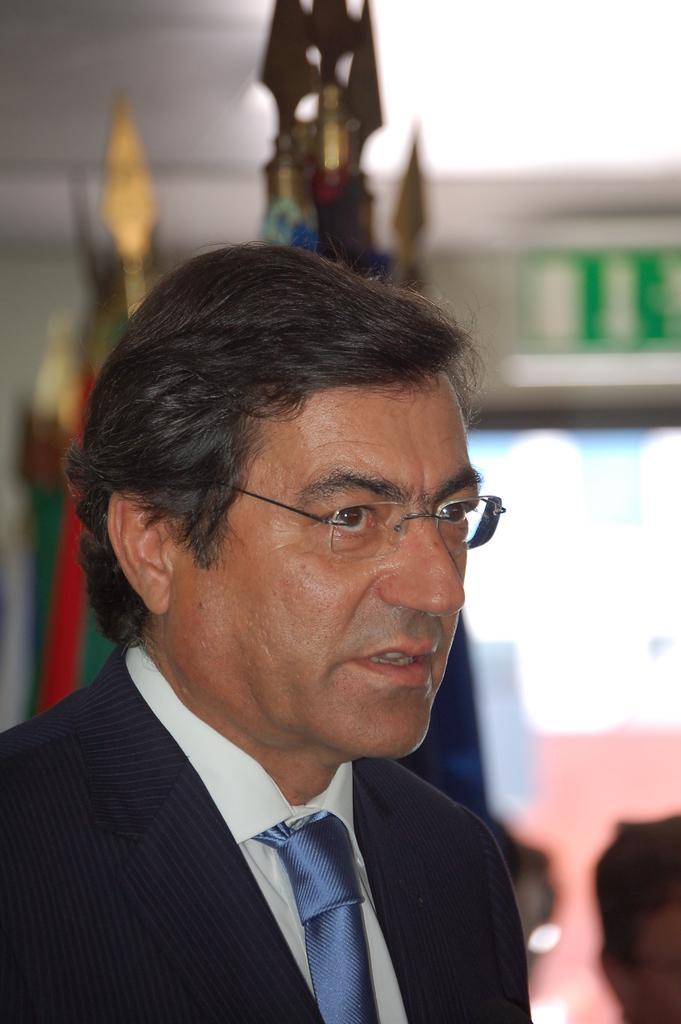In one or two sentences, can you explain what this image depicts? In this image we can see a man. In the bottom right we can see another person. There are few objects behind the man. The background of the image is blurred. 